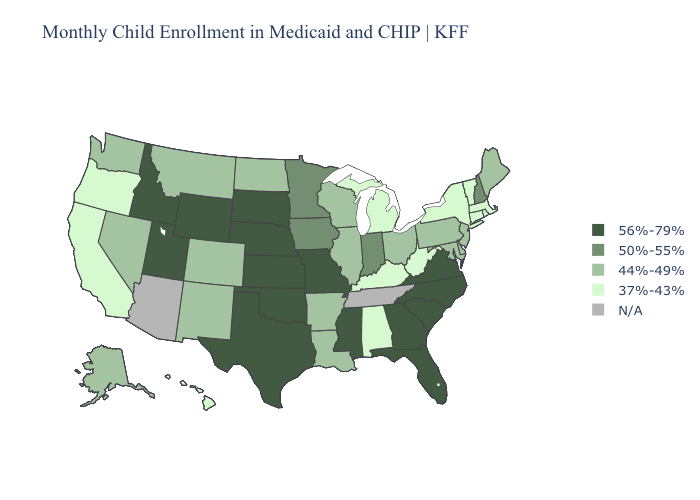Name the states that have a value in the range N/A?
Give a very brief answer. Arizona, Tennessee. Does West Virginia have the highest value in the South?
Write a very short answer. No. What is the value of Kansas?
Concise answer only. 56%-79%. Name the states that have a value in the range N/A?
Concise answer only. Arizona, Tennessee. Name the states that have a value in the range 44%-49%?
Quick response, please. Alaska, Arkansas, Colorado, Delaware, Illinois, Louisiana, Maine, Maryland, Montana, Nevada, New Jersey, New Mexico, North Dakota, Ohio, Pennsylvania, Washington, Wisconsin. Name the states that have a value in the range 37%-43%?
Answer briefly. Alabama, California, Connecticut, Hawaii, Kentucky, Massachusetts, Michigan, New York, Oregon, Rhode Island, Vermont, West Virginia. Does Kansas have the highest value in the USA?
Concise answer only. Yes. What is the value of Delaware?
Keep it brief. 44%-49%. Does Kansas have the highest value in the USA?
Answer briefly. Yes. Name the states that have a value in the range N/A?
Be succinct. Arizona, Tennessee. What is the lowest value in the USA?
Be succinct. 37%-43%. 